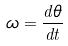Convert formula to latex. <formula><loc_0><loc_0><loc_500><loc_500>\omega = \frac { d \theta } { d t }</formula> 